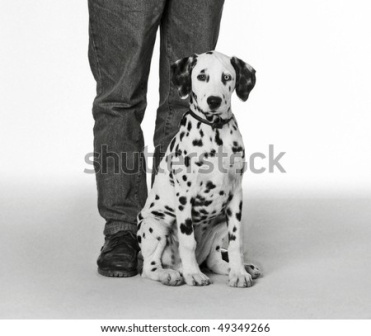What emotions does the image evoke and why? The image evokes emotions of warmth, affection, and companionship. The Dalmatian puppy's attentive and curious gaze towards the person suggests a strong bond and a sense of trust. The simplicity of the white background and the casual attire of the person contributes to a feeling of comfort and everyday life, highlighting the unspoken understanding and loyalty between humans and their pets. Can you imagine a short story inspired by this image? Once upon a time, in a quaint little town, a young Dalmatian puppy named Dotty was adopted by a kind-hearted artist named Emma. Every morning, Dotty would eagerly sit by Emma’s side as she painted serene landscapes and vibrant portraits. One day, Dotty noticed Emma seemed a bit sad, so she sat even closer, her curious eyes never leaving Emma's face. Emma looked down at Dotty and smiled, her sadness melting away. She realized that in Dotty's devoted gaze, she found a muse and a silent companion who filled her heart with joy and inspiration. 